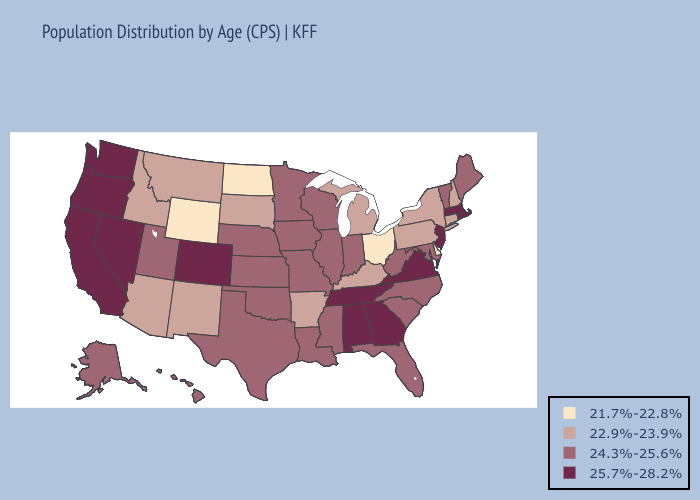Does the map have missing data?
Answer briefly. No. Name the states that have a value in the range 24.3%-25.6%?
Keep it brief. Alaska, Florida, Hawaii, Illinois, Indiana, Iowa, Kansas, Louisiana, Maine, Maryland, Minnesota, Mississippi, Missouri, Nebraska, North Carolina, Oklahoma, South Carolina, Texas, Utah, Vermont, West Virginia, Wisconsin. Name the states that have a value in the range 25.7%-28.2%?
Give a very brief answer. Alabama, California, Colorado, Georgia, Massachusetts, Nevada, New Jersey, Oregon, Rhode Island, Tennessee, Virginia, Washington. Does Alabama have a higher value than Washington?
Quick response, please. No. Name the states that have a value in the range 21.7%-22.8%?
Answer briefly. Delaware, North Dakota, Ohio, Wyoming. Which states hav the highest value in the South?
Quick response, please. Alabama, Georgia, Tennessee, Virginia. What is the value of Massachusetts?
Short answer required. 25.7%-28.2%. Among the states that border Minnesota , does South Dakota have the lowest value?
Keep it brief. No. Among the states that border Michigan , does Wisconsin have the lowest value?
Short answer required. No. Among the states that border Indiana , does Illinois have the highest value?
Keep it brief. Yes. What is the highest value in the South ?
Write a very short answer. 25.7%-28.2%. Does Arizona have the lowest value in the USA?
Quick response, please. No. Among the states that border Montana , which have the lowest value?
Be succinct. North Dakota, Wyoming. Which states have the lowest value in the South?
Concise answer only. Delaware. 